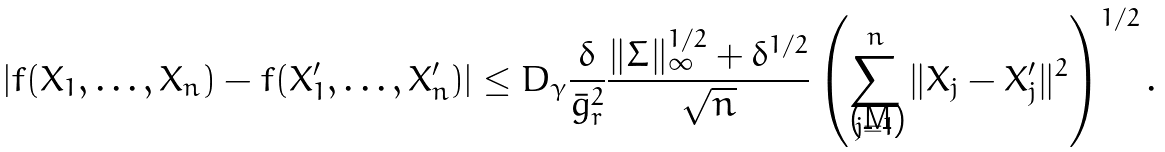<formula> <loc_0><loc_0><loc_500><loc_500>| f ( X _ { 1 } , \dots , X _ { n } ) - f ( X _ { 1 } ^ { \prime } , \dots , X _ { n } ^ { \prime } ) | \leq D _ { \gamma } \frac { \delta } { \bar { g } _ { r } ^ { 2 } } \frac { \| \Sigma \| _ { \infty } ^ { 1 / 2 } + \delta ^ { 1 / 2 } } { \sqrt { n } } \left ( \sum _ { j = 1 } ^ { n } \| X _ { j } - X _ { j } ^ { \prime } \| ^ { 2 } \right ) ^ { 1 / 2 } .</formula> 